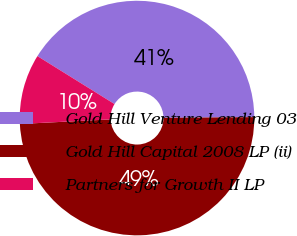<chart> <loc_0><loc_0><loc_500><loc_500><pie_chart><fcel>Gold Hill Venture Lending 03<fcel>Gold Hill Capital 2008 LP (ii)<fcel>Partners for Growth II LP<nl><fcel>41.02%<fcel>49.32%<fcel>9.66%<nl></chart> 